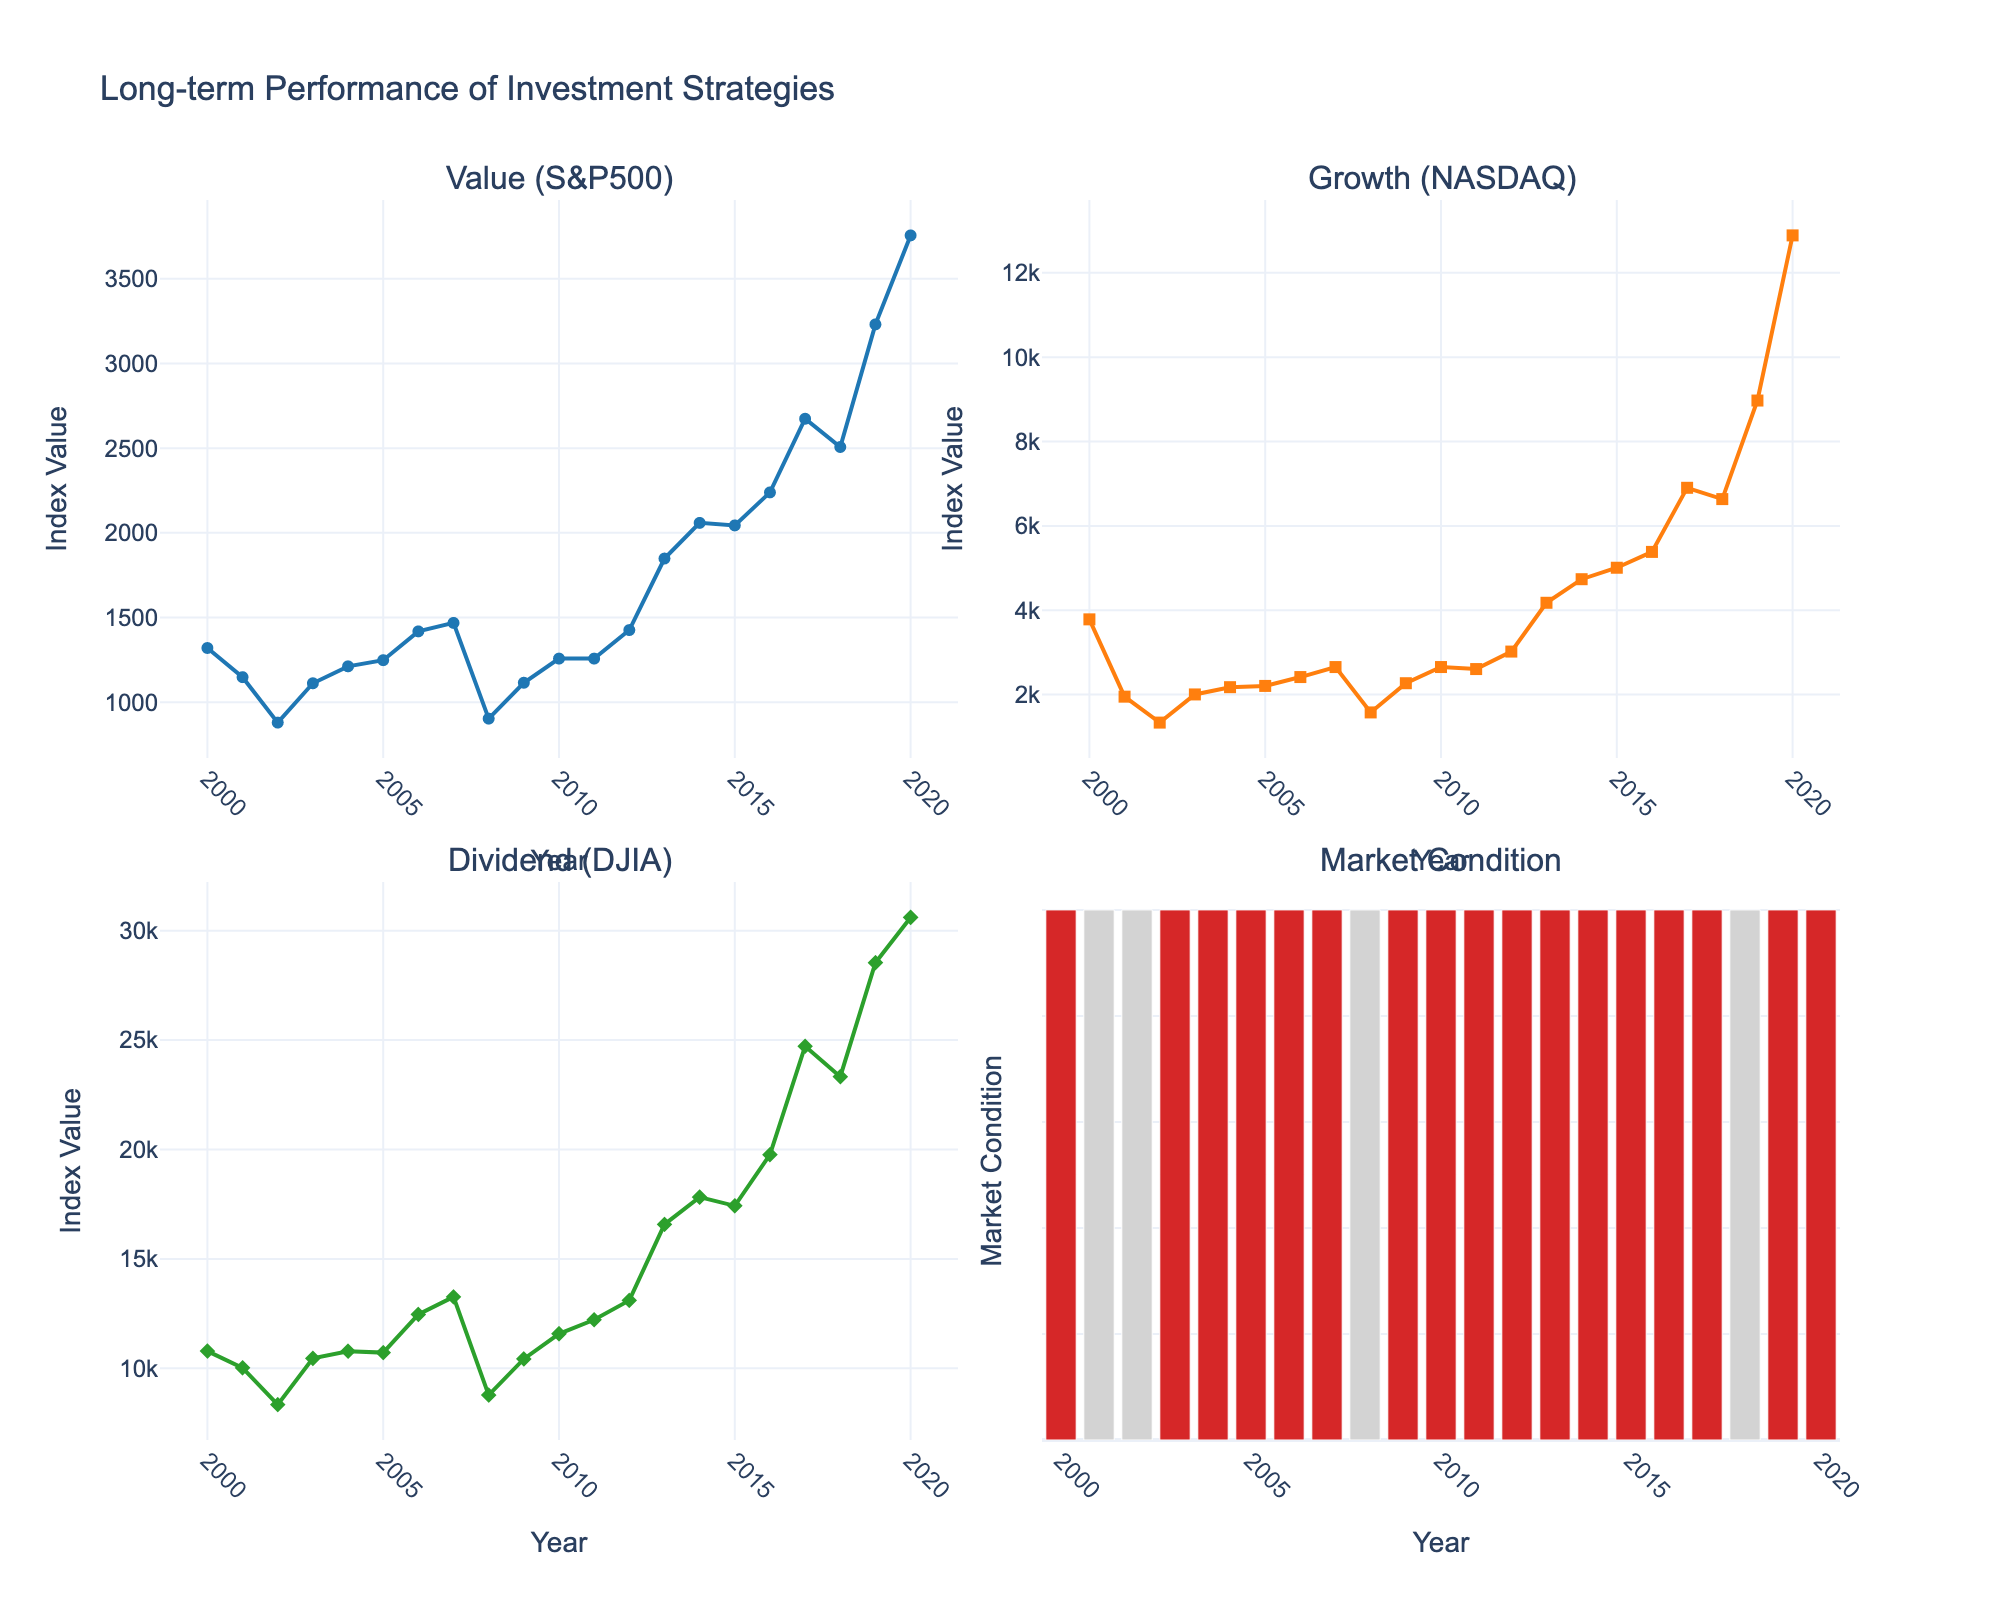What's the title of the figure? The title is located at the top of the figure as it summarizes the content presented in the subplots. The title reads "Long-term Performance of Investment Strategies".
Answer: Long-term Performance of Investment Strategies Which subplot shows the performance of Dividend (DJIA)? The Dividend (DJIA) subplot is located at the bottom-left corner of the figure, indicated by its title and the y-axis labeled "Dividend (DJIA)".
Answer: Bottom-left How does the market condition change in 2008? The bar corresponding to the year 2008 in the Market Condition subplot is colored light gray, indicating a "Bear" market condition.
Answer: Bear What is the index value of Growth (NASDAQ) in the year 2001? In the subplot for Growth (NASDAQ), the line corresponding to the year 2001 shows a value of approximately 1950.40.
Answer: 1950.40 What is the overall trend for the Value (S&P500) strategy from 2000 to 2020? Observing the Value (S&P500) subplot, the line shows a general upward trend from around 1320.28 in 2000 to 3756.07 in 2020.
Answer: Upward How many years experienced a Bear market condition based on the figure? Count the number of light gray bars in the Market Condition subplot to determine the number of Bear market years, which are 2001, 2002, 2008, and 2018.
Answer: 4 Which investment strategy had the highest index value in 2020? In 2020, the index values for the subplots are: Value (S&P500) ~3756.07, Growth (NASDAQ) ~12888.28, and Dividend (DJIA) ~30606.48. The highest among them is from the Growth (NASDAQ) subplot.
Answer: Growth (NASDAQ) What was the difference in index values between Growth (NASDAQ) and Value (S&P500) in 2010? The index value of Growth (NASDAQ) in 2010 is approximately 2652.87 and Value (S&P500) is 1257.64. The difference is 2652.87 - 1257.64.
Answer: 1395.23 During Bear market conditions, which investment strategy showed the lowest index value on average? Identify the index values during Bear market years (2001, 2002, 2008, 2018) for each strategy and compute averages. Value (S&P500): (1148.08 + 879.82 + 903.25 + 2506.85)/4, Growth (NASDAQ): (1950.40 + 1335.51 + 1577.03 + 6635.28)/4, Dividend (DJIA): (10021.57 + 8341.63 + 8776.39 + 23327.46)/4. Compare the averages. The lowest is Growth (NASDAQ).
Answer: Growth (NASDAQ) Is there any year where the Value (S&P500) and Dividend (DJIA) had similar index values? Compare the lines of Value (S&P500) and Dividend (DJIA) to find any years where their values are close. In 2004, the index values are relatively close: Value (S&P500) ~1211.92 and Dividend (DJIA) ~10783.01.
Answer: No 